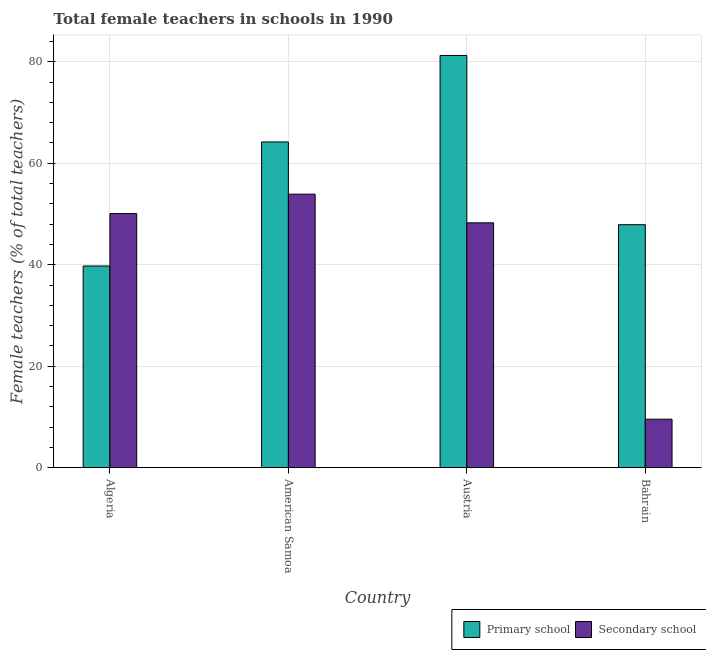How many groups of bars are there?
Offer a very short reply. 4. How many bars are there on the 3rd tick from the right?
Keep it short and to the point. 2. What is the label of the 3rd group of bars from the left?
Provide a succinct answer. Austria. In how many cases, is the number of bars for a given country not equal to the number of legend labels?
Keep it short and to the point. 0. What is the percentage of female teachers in secondary schools in Bahrain?
Make the answer very short. 9.55. Across all countries, what is the maximum percentage of female teachers in primary schools?
Your answer should be compact. 81.25. Across all countries, what is the minimum percentage of female teachers in secondary schools?
Give a very brief answer. 9.55. In which country was the percentage of female teachers in secondary schools maximum?
Your answer should be compact. American Samoa. In which country was the percentage of female teachers in primary schools minimum?
Your answer should be compact. Algeria. What is the total percentage of female teachers in primary schools in the graph?
Make the answer very short. 233.1. What is the difference between the percentage of female teachers in secondary schools in American Samoa and that in Bahrain?
Provide a short and direct response. 44.36. What is the difference between the percentage of female teachers in secondary schools in Bahrain and the percentage of female teachers in primary schools in Austria?
Make the answer very short. -71.7. What is the average percentage of female teachers in secondary schools per country?
Offer a very short reply. 40.45. What is the difference between the percentage of female teachers in primary schools and percentage of female teachers in secondary schools in Algeria?
Offer a terse response. -10.34. What is the ratio of the percentage of female teachers in secondary schools in Algeria to that in Austria?
Give a very brief answer. 1.04. Is the difference between the percentage of female teachers in primary schools in American Samoa and Austria greater than the difference between the percentage of female teachers in secondary schools in American Samoa and Austria?
Your response must be concise. No. What is the difference between the highest and the second highest percentage of female teachers in secondary schools?
Your answer should be compact. 3.82. What is the difference between the highest and the lowest percentage of female teachers in secondary schools?
Offer a terse response. 44.36. In how many countries, is the percentage of female teachers in secondary schools greater than the average percentage of female teachers in secondary schools taken over all countries?
Provide a succinct answer. 3. Is the sum of the percentage of female teachers in secondary schools in Algeria and American Samoa greater than the maximum percentage of female teachers in primary schools across all countries?
Keep it short and to the point. Yes. What does the 2nd bar from the left in Algeria represents?
Provide a succinct answer. Secondary school. What does the 2nd bar from the right in Austria represents?
Provide a succinct answer. Primary school. Are all the bars in the graph horizontal?
Offer a very short reply. No. How many countries are there in the graph?
Make the answer very short. 4. Are the values on the major ticks of Y-axis written in scientific E-notation?
Keep it short and to the point. No. Does the graph contain any zero values?
Offer a very short reply. No. Does the graph contain grids?
Give a very brief answer. Yes. How are the legend labels stacked?
Offer a very short reply. Horizontal. What is the title of the graph?
Provide a short and direct response. Total female teachers in schools in 1990. Does "By country of asylum" appear as one of the legend labels in the graph?
Your response must be concise. No. What is the label or title of the X-axis?
Offer a very short reply. Country. What is the label or title of the Y-axis?
Give a very brief answer. Female teachers (% of total teachers). What is the Female teachers (% of total teachers) of Primary school in Algeria?
Offer a very short reply. 39.75. What is the Female teachers (% of total teachers) of Secondary school in Algeria?
Offer a very short reply. 50.09. What is the Female teachers (% of total teachers) of Primary school in American Samoa?
Offer a very short reply. 64.21. What is the Female teachers (% of total teachers) in Secondary school in American Samoa?
Provide a succinct answer. 53.91. What is the Female teachers (% of total teachers) of Primary school in Austria?
Give a very brief answer. 81.25. What is the Female teachers (% of total teachers) in Secondary school in Austria?
Offer a terse response. 48.27. What is the Female teachers (% of total teachers) in Primary school in Bahrain?
Make the answer very short. 47.89. What is the Female teachers (% of total teachers) in Secondary school in Bahrain?
Make the answer very short. 9.55. Across all countries, what is the maximum Female teachers (% of total teachers) of Primary school?
Provide a short and direct response. 81.25. Across all countries, what is the maximum Female teachers (% of total teachers) in Secondary school?
Make the answer very short. 53.91. Across all countries, what is the minimum Female teachers (% of total teachers) in Primary school?
Give a very brief answer. 39.75. Across all countries, what is the minimum Female teachers (% of total teachers) of Secondary school?
Provide a succinct answer. 9.55. What is the total Female teachers (% of total teachers) in Primary school in the graph?
Ensure brevity in your answer.  233.1. What is the total Female teachers (% of total teachers) of Secondary school in the graph?
Keep it short and to the point. 161.82. What is the difference between the Female teachers (% of total teachers) in Primary school in Algeria and that in American Samoa?
Give a very brief answer. -24.46. What is the difference between the Female teachers (% of total teachers) of Secondary school in Algeria and that in American Samoa?
Offer a very short reply. -3.82. What is the difference between the Female teachers (% of total teachers) of Primary school in Algeria and that in Austria?
Keep it short and to the point. -41.5. What is the difference between the Female teachers (% of total teachers) of Secondary school in Algeria and that in Austria?
Provide a succinct answer. 1.83. What is the difference between the Female teachers (% of total teachers) of Primary school in Algeria and that in Bahrain?
Keep it short and to the point. -8.14. What is the difference between the Female teachers (% of total teachers) of Secondary school in Algeria and that in Bahrain?
Ensure brevity in your answer.  40.54. What is the difference between the Female teachers (% of total teachers) of Primary school in American Samoa and that in Austria?
Offer a terse response. -17.04. What is the difference between the Female teachers (% of total teachers) in Secondary school in American Samoa and that in Austria?
Your answer should be compact. 5.64. What is the difference between the Female teachers (% of total teachers) in Primary school in American Samoa and that in Bahrain?
Make the answer very short. 16.32. What is the difference between the Female teachers (% of total teachers) in Secondary school in American Samoa and that in Bahrain?
Keep it short and to the point. 44.36. What is the difference between the Female teachers (% of total teachers) in Primary school in Austria and that in Bahrain?
Offer a very short reply. 33.36. What is the difference between the Female teachers (% of total teachers) in Secondary school in Austria and that in Bahrain?
Give a very brief answer. 38.71. What is the difference between the Female teachers (% of total teachers) in Primary school in Algeria and the Female teachers (% of total teachers) in Secondary school in American Samoa?
Offer a very short reply. -14.16. What is the difference between the Female teachers (% of total teachers) of Primary school in Algeria and the Female teachers (% of total teachers) of Secondary school in Austria?
Ensure brevity in your answer.  -8.51. What is the difference between the Female teachers (% of total teachers) in Primary school in Algeria and the Female teachers (% of total teachers) in Secondary school in Bahrain?
Provide a succinct answer. 30.2. What is the difference between the Female teachers (% of total teachers) in Primary school in American Samoa and the Female teachers (% of total teachers) in Secondary school in Austria?
Provide a short and direct response. 15.94. What is the difference between the Female teachers (% of total teachers) in Primary school in American Samoa and the Female teachers (% of total teachers) in Secondary school in Bahrain?
Make the answer very short. 54.66. What is the difference between the Female teachers (% of total teachers) in Primary school in Austria and the Female teachers (% of total teachers) in Secondary school in Bahrain?
Offer a very short reply. 71.7. What is the average Female teachers (% of total teachers) of Primary school per country?
Provide a short and direct response. 58.28. What is the average Female teachers (% of total teachers) of Secondary school per country?
Provide a short and direct response. 40.45. What is the difference between the Female teachers (% of total teachers) of Primary school and Female teachers (% of total teachers) of Secondary school in Algeria?
Ensure brevity in your answer.  -10.34. What is the difference between the Female teachers (% of total teachers) of Primary school and Female teachers (% of total teachers) of Secondary school in American Samoa?
Give a very brief answer. 10.3. What is the difference between the Female teachers (% of total teachers) in Primary school and Female teachers (% of total teachers) in Secondary school in Austria?
Offer a very short reply. 32.99. What is the difference between the Female teachers (% of total teachers) in Primary school and Female teachers (% of total teachers) in Secondary school in Bahrain?
Offer a very short reply. 38.34. What is the ratio of the Female teachers (% of total teachers) of Primary school in Algeria to that in American Samoa?
Ensure brevity in your answer.  0.62. What is the ratio of the Female teachers (% of total teachers) in Secondary school in Algeria to that in American Samoa?
Give a very brief answer. 0.93. What is the ratio of the Female teachers (% of total teachers) in Primary school in Algeria to that in Austria?
Your answer should be very brief. 0.49. What is the ratio of the Female teachers (% of total teachers) in Secondary school in Algeria to that in Austria?
Your response must be concise. 1.04. What is the ratio of the Female teachers (% of total teachers) of Primary school in Algeria to that in Bahrain?
Offer a terse response. 0.83. What is the ratio of the Female teachers (% of total teachers) in Secondary school in Algeria to that in Bahrain?
Provide a succinct answer. 5.24. What is the ratio of the Female teachers (% of total teachers) of Primary school in American Samoa to that in Austria?
Your response must be concise. 0.79. What is the ratio of the Female teachers (% of total teachers) in Secondary school in American Samoa to that in Austria?
Offer a terse response. 1.12. What is the ratio of the Female teachers (% of total teachers) in Primary school in American Samoa to that in Bahrain?
Provide a succinct answer. 1.34. What is the ratio of the Female teachers (% of total teachers) of Secondary school in American Samoa to that in Bahrain?
Provide a short and direct response. 5.64. What is the ratio of the Female teachers (% of total teachers) in Primary school in Austria to that in Bahrain?
Ensure brevity in your answer.  1.7. What is the ratio of the Female teachers (% of total teachers) of Secondary school in Austria to that in Bahrain?
Your answer should be very brief. 5.05. What is the difference between the highest and the second highest Female teachers (% of total teachers) of Primary school?
Make the answer very short. 17.04. What is the difference between the highest and the second highest Female teachers (% of total teachers) in Secondary school?
Provide a succinct answer. 3.82. What is the difference between the highest and the lowest Female teachers (% of total teachers) in Primary school?
Your response must be concise. 41.5. What is the difference between the highest and the lowest Female teachers (% of total teachers) of Secondary school?
Your answer should be compact. 44.36. 